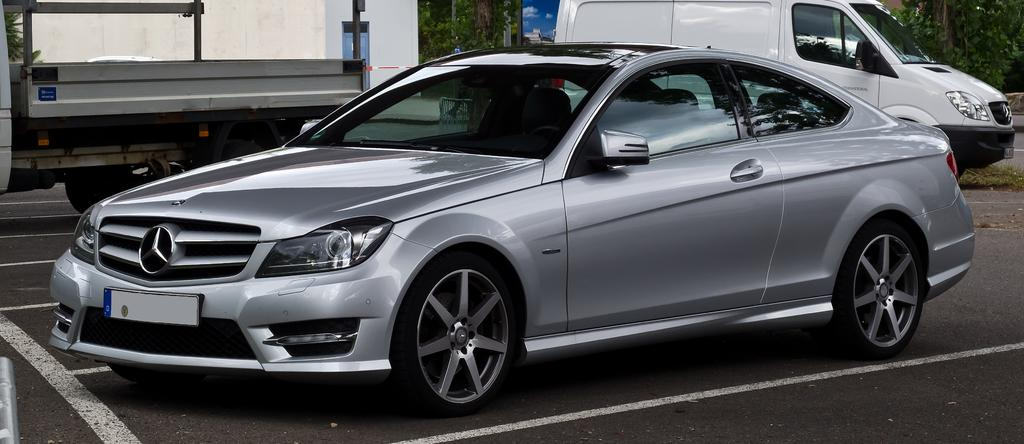What type of vehicle is located in the front of the image? There is a car in the front of the image. What other vehicle can be seen in the image? There is a van on the right side of the image. What can be seen in the distance in the image? There are trees in the background of the image. What structure is visible in the image? There is a wall visible in the image. What type of plough is being used to make a decision in the image? There is no plough or decision-making process depicted in the image. What type of love can be seen between the car and the van in the image? There is no representation of love between the car and the van in the image; they are simply vehicles parked next to each other. 